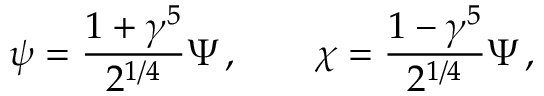<formula> <loc_0><loc_0><loc_500><loc_500>\psi = \frac { 1 + \gamma ^ { 5 } } { 2 ^ { 1 / 4 } } \Psi \, , \quad \chi = \frac { 1 - \gamma ^ { 5 } } { 2 ^ { 1 / 4 } } \Psi \, ,</formula> 